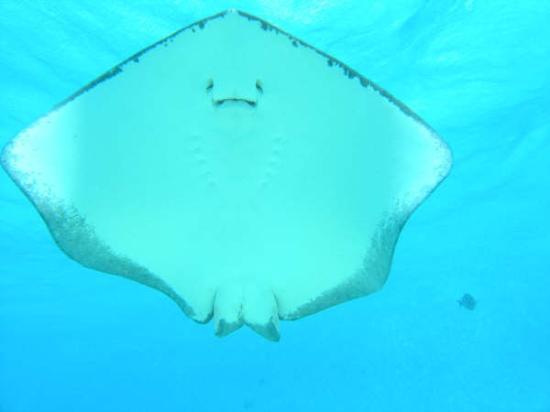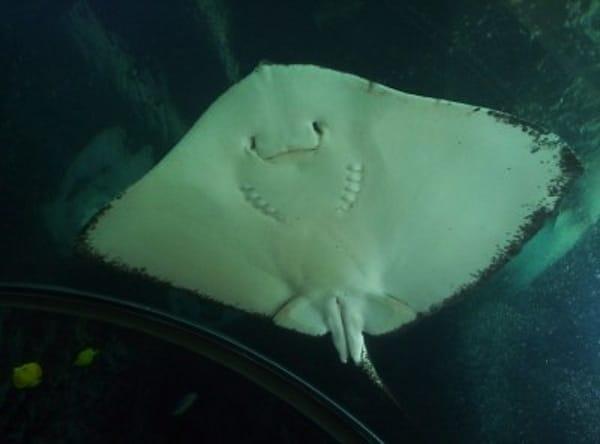The first image is the image on the left, the second image is the image on the right. For the images displayed, is the sentence "All images show an upright stingray with wings extended and underside visible." factually correct? Answer yes or no. Yes. 